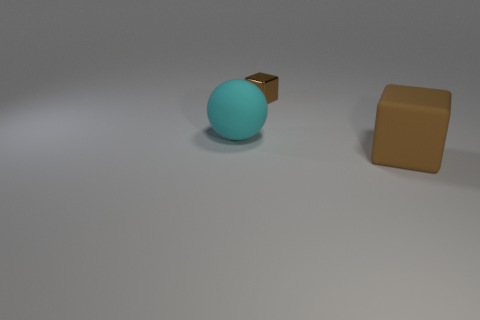Is there another thing that has the same size as the cyan matte object?
Ensure brevity in your answer.  Yes. There is a large matte thing on the right side of the cyan matte thing; is its color the same as the tiny object?
Make the answer very short. Yes. What number of objects are either large cyan balls or metal things?
Provide a short and direct response. 2. Do the brown thing in front of the shiny block and the metallic cube have the same size?
Offer a terse response. No. How big is the object that is in front of the small metallic object and on the right side of the cyan matte object?
Keep it short and to the point. Large. What number of other objects are the same shape as the big brown matte thing?
Keep it short and to the point. 1. How many other objects are there of the same material as the cyan sphere?
Keep it short and to the point. 1. There is a metallic object that is the same shape as the brown matte object; what size is it?
Your answer should be compact. Small. Is the matte block the same color as the small metallic thing?
Keep it short and to the point. Yes. The object that is in front of the small metal object and behind the large cube is what color?
Offer a terse response. Cyan. 